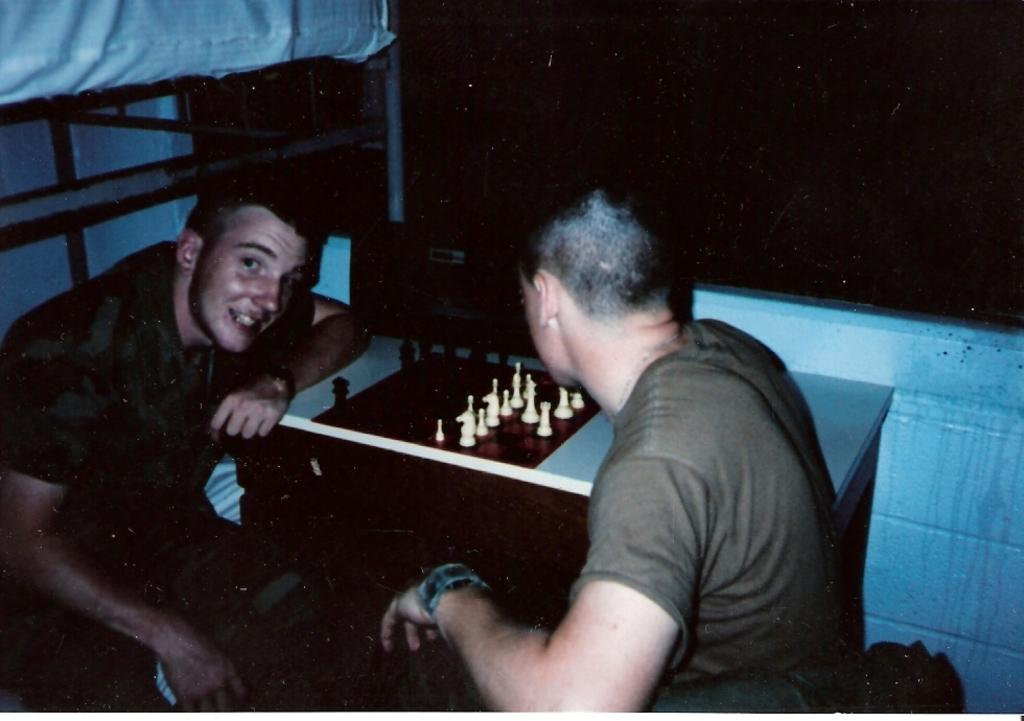How many people are present in the image? There are two people sitting in the image. What is in front of the people? There is a table in front of the people. What is on the table? There is a chess board and coins on the table. What type of frame is surrounding the chess board in the image? There is no frame surrounding the chess board in the image. How are the coins distributed on the table in the image? The distribution of coins on the table cannot be determined from the image alone. 